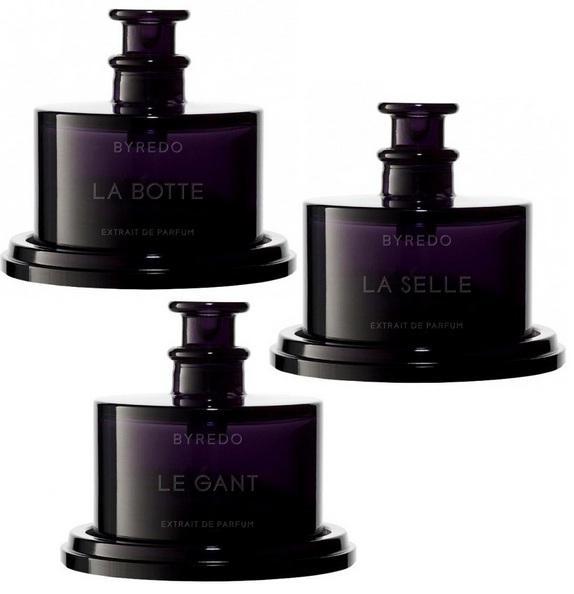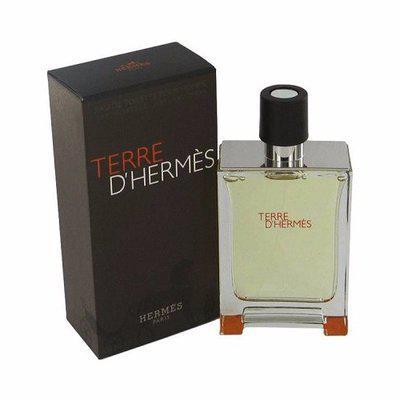The first image is the image on the left, the second image is the image on the right. Analyze the images presented: Is the assertion "An image shows a trio of fragance bottles of the same size and shape, displayed in a triangular formation." valid? Answer yes or no. Yes. 